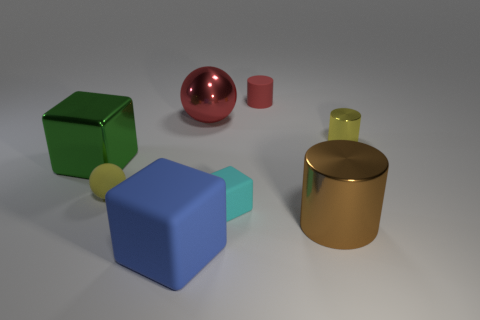Subtract all purple cylinders. Subtract all purple spheres. How many cylinders are left? 3 Add 1 small yellow metal cylinders. How many objects exist? 9 Subtract all blocks. How many objects are left? 5 Add 1 red spheres. How many red spheres exist? 2 Subtract 0 blue cylinders. How many objects are left? 8 Subtract all large rubber blocks. Subtract all large red shiny balls. How many objects are left? 6 Add 5 small rubber blocks. How many small rubber blocks are left? 6 